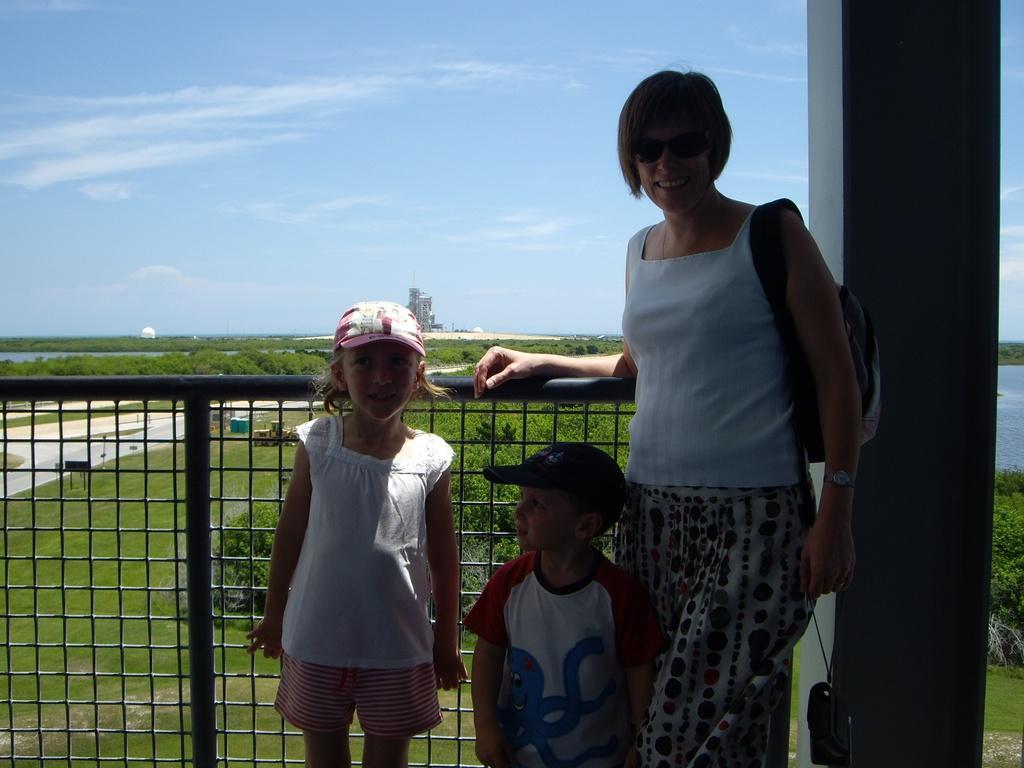In one or two sentences, can you explain what this image depicts? In this image we can see three people standing. On the right there is a pillar and we can see a grille. In the background there are trees, tower and sky. 